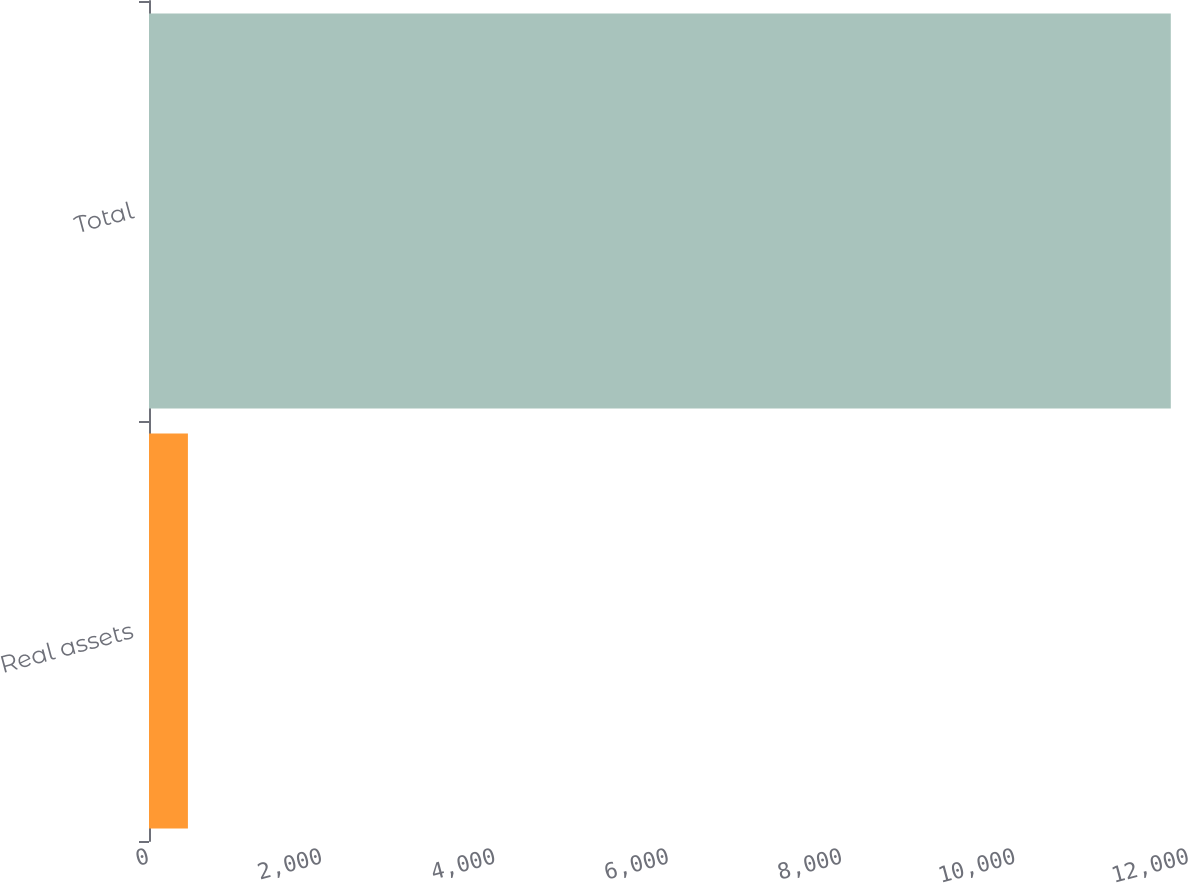<chart> <loc_0><loc_0><loc_500><loc_500><bar_chart><fcel>Real assets<fcel>Total<nl><fcel>449<fcel>11790<nl></chart> 